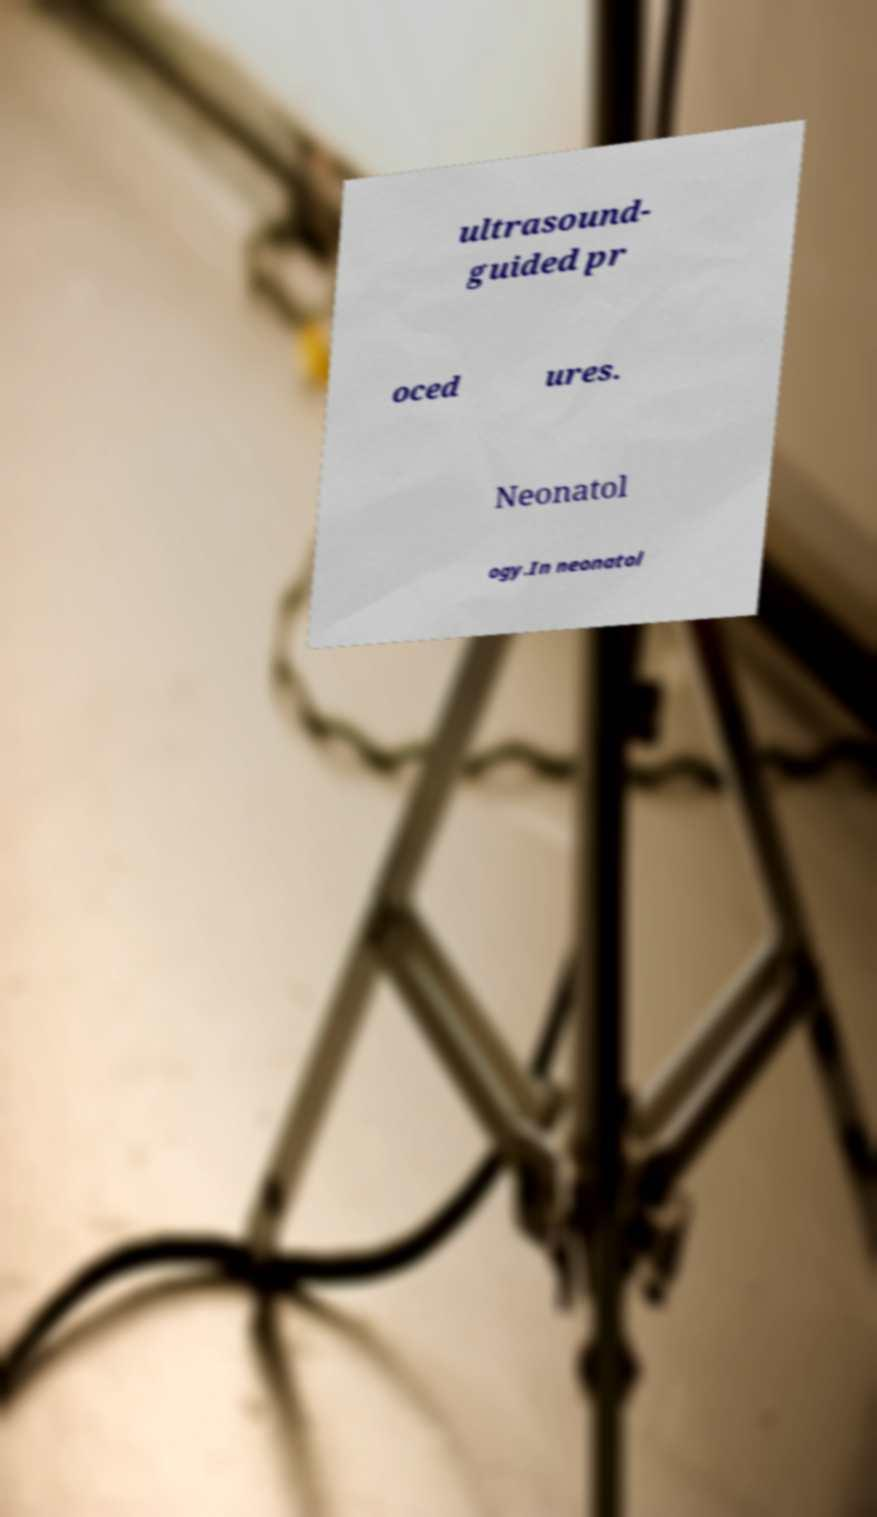There's text embedded in this image that I need extracted. Can you transcribe it verbatim? ultrasound- guided pr oced ures. Neonatol ogy.In neonatol 